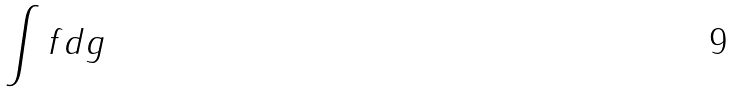<formula> <loc_0><loc_0><loc_500><loc_500>\int f d g</formula> 